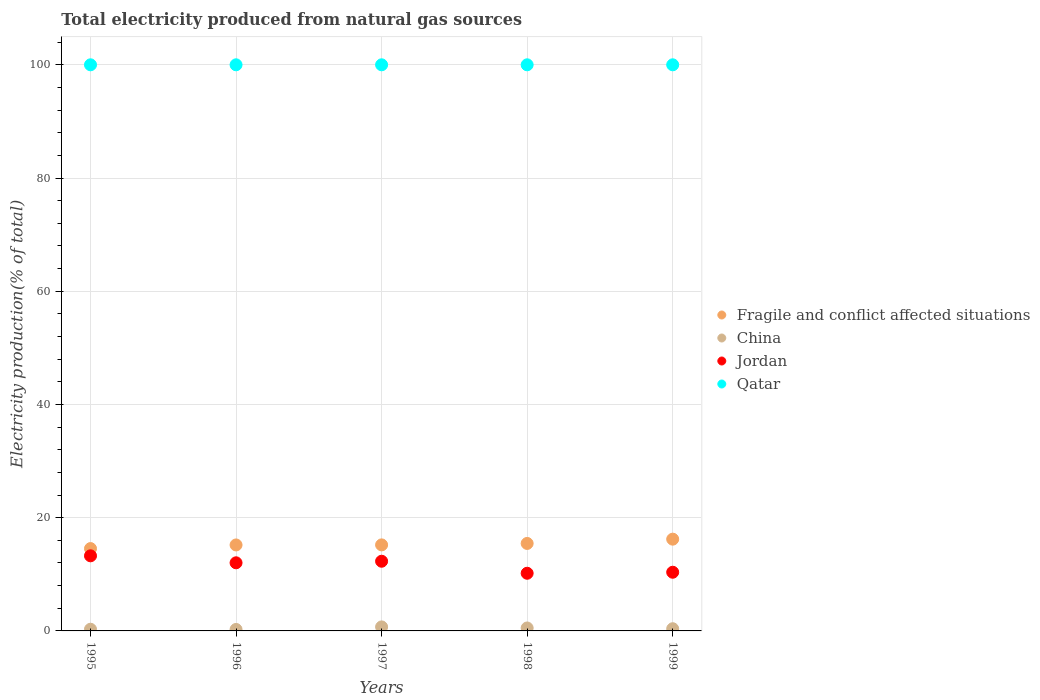Is the number of dotlines equal to the number of legend labels?
Provide a short and direct response. Yes. What is the total electricity produced in Jordan in 1995?
Provide a succinct answer. 13.27. What is the total total electricity produced in Jordan in the graph?
Ensure brevity in your answer.  58.16. What is the difference between the total electricity produced in China in 1996 and that in 1999?
Make the answer very short. -0.13. What is the difference between the total electricity produced in Qatar in 1995 and the total electricity produced in Jordan in 1999?
Make the answer very short. 89.63. In the year 1995, what is the difference between the total electricity produced in Fragile and conflict affected situations and total electricity produced in Jordan?
Make the answer very short. 1.28. In how many years, is the total electricity produced in Qatar greater than 68 %?
Keep it short and to the point. 5. What is the difference between the highest and the second highest total electricity produced in Jordan?
Your answer should be very brief. 0.96. What is the difference between the highest and the lowest total electricity produced in Jordan?
Make the answer very short. 3.08. Is the sum of the total electricity produced in Qatar in 1996 and 1997 greater than the maximum total electricity produced in China across all years?
Your answer should be compact. Yes. Is it the case that in every year, the sum of the total electricity produced in Fragile and conflict affected situations and total electricity produced in Qatar  is greater than the sum of total electricity produced in Jordan and total electricity produced in China?
Make the answer very short. Yes. Is it the case that in every year, the sum of the total electricity produced in Jordan and total electricity produced in China  is greater than the total electricity produced in Fragile and conflict affected situations?
Keep it short and to the point. No. Is the total electricity produced in Jordan strictly less than the total electricity produced in Qatar over the years?
Offer a very short reply. Yes. How many years are there in the graph?
Give a very brief answer. 5. What is the difference between two consecutive major ticks on the Y-axis?
Provide a succinct answer. 20. Are the values on the major ticks of Y-axis written in scientific E-notation?
Your answer should be very brief. No. Does the graph contain any zero values?
Make the answer very short. No. Does the graph contain grids?
Provide a succinct answer. Yes. Where does the legend appear in the graph?
Make the answer very short. Center right. How many legend labels are there?
Offer a very short reply. 4. How are the legend labels stacked?
Keep it short and to the point. Vertical. What is the title of the graph?
Make the answer very short. Total electricity produced from natural gas sources. Does "Morocco" appear as one of the legend labels in the graph?
Your answer should be very brief. No. What is the label or title of the Y-axis?
Your answer should be very brief. Electricity production(% of total). What is the Electricity production(% of total) of Fragile and conflict affected situations in 1995?
Your answer should be very brief. 14.55. What is the Electricity production(% of total) in China in 1995?
Your response must be concise. 0.3. What is the Electricity production(% of total) in Jordan in 1995?
Ensure brevity in your answer.  13.27. What is the Electricity production(% of total) of Qatar in 1995?
Your answer should be compact. 100. What is the Electricity production(% of total) of Fragile and conflict affected situations in 1996?
Offer a very short reply. 15.19. What is the Electricity production(% of total) in China in 1996?
Keep it short and to the point. 0.26. What is the Electricity production(% of total) in Jordan in 1996?
Your response must be concise. 12.03. What is the Electricity production(% of total) in Fragile and conflict affected situations in 1997?
Ensure brevity in your answer.  15.2. What is the Electricity production(% of total) in China in 1997?
Offer a terse response. 0.71. What is the Electricity production(% of total) in Jordan in 1997?
Keep it short and to the point. 12.31. What is the Electricity production(% of total) in Qatar in 1997?
Ensure brevity in your answer.  100. What is the Electricity production(% of total) in Fragile and conflict affected situations in 1998?
Offer a terse response. 15.45. What is the Electricity production(% of total) of China in 1998?
Offer a terse response. 0.52. What is the Electricity production(% of total) in Jordan in 1998?
Your answer should be compact. 10.19. What is the Electricity production(% of total) in Qatar in 1998?
Give a very brief answer. 100. What is the Electricity production(% of total) in Fragile and conflict affected situations in 1999?
Offer a very short reply. 16.21. What is the Electricity production(% of total) of China in 1999?
Your answer should be very brief. 0.39. What is the Electricity production(% of total) in Jordan in 1999?
Make the answer very short. 10.37. What is the Electricity production(% of total) in Qatar in 1999?
Provide a succinct answer. 100. Across all years, what is the maximum Electricity production(% of total) in Fragile and conflict affected situations?
Give a very brief answer. 16.21. Across all years, what is the maximum Electricity production(% of total) of China?
Your answer should be very brief. 0.71. Across all years, what is the maximum Electricity production(% of total) in Jordan?
Give a very brief answer. 13.27. Across all years, what is the maximum Electricity production(% of total) of Qatar?
Give a very brief answer. 100. Across all years, what is the minimum Electricity production(% of total) in Fragile and conflict affected situations?
Provide a short and direct response. 14.55. Across all years, what is the minimum Electricity production(% of total) in China?
Provide a succinct answer. 0.26. Across all years, what is the minimum Electricity production(% of total) of Jordan?
Your answer should be compact. 10.19. What is the total Electricity production(% of total) of Fragile and conflict affected situations in the graph?
Provide a succinct answer. 76.59. What is the total Electricity production(% of total) of China in the graph?
Make the answer very short. 2.17. What is the total Electricity production(% of total) of Jordan in the graph?
Offer a very short reply. 58.16. What is the total Electricity production(% of total) of Qatar in the graph?
Offer a very short reply. 500. What is the difference between the Electricity production(% of total) of Fragile and conflict affected situations in 1995 and that in 1996?
Provide a short and direct response. -0.64. What is the difference between the Electricity production(% of total) of China in 1995 and that in 1996?
Keep it short and to the point. 0.04. What is the difference between the Electricity production(% of total) of Jordan in 1995 and that in 1996?
Your answer should be very brief. 1.23. What is the difference between the Electricity production(% of total) of Fragile and conflict affected situations in 1995 and that in 1997?
Make the answer very short. -0.65. What is the difference between the Electricity production(% of total) in China in 1995 and that in 1997?
Provide a succinct answer. -0.41. What is the difference between the Electricity production(% of total) of Jordan in 1995 and that in 1997?
Give a very brief answer. 0.96. What is the difference between the Electricity production(% of total) in Fragile and conflict affected situations in 1995 and that in 1998?
Keep it short and to the point. -0.91. What is the difference between the Electricity production(% of total) in China in 1995 and that in 1998?
Give a very brief answer. -0.22. What is the difference between the Electricity production(% of total) in Jordan in 1995 and that in 1998?
Give a very brief answer. 3.08. What is the difference between the Electricity production(% of total) of Qatar in 1995 and that in 1998?
Keep it short and to the point. 0. What is the difference between the Electricity production(% of total) in Fragile and conflict affected situations in 1995 and that in 1999?
Provide a succinct answer. -1.66. What is the difference between the Electricity production(% of total) in China in 1995 and that in 1999?
Provide a succinct answer. -0.09. What is the difference between the Electricity production(% of total) in Jordan in 1995 and that in 1999?
Offer a terse response. 2.9. What is the difference between the Electricity production(% of total) in Fragile and conflict affected situations in 1996 and that in 1997?
Give a very brief answer. -0.01. What is the difference between the Electricity production(% of total) of China in 1996 and that in 1997?
Ensure brevity in your answer.  -0.45. What is the difference between the Electricity production(% of total) in Jordan in 1996 and that in 1997?
Your answer should be very brief. -0.27. What is the difference between the Electricity production(% of total) in Qatar in 1996 and that in 1997?
Offer a terse response. 0. What is the difference between the Electricity production(% of total) in Fragile and conflict affected situations in 1996 and that in 1998?
Provide a succinct answer. -0.27. What is the difference between the Electricity production(% of total) in China in 1996 and that in 1998?
Offer a terse response. -0.26. What is the difference between the Electricity production(% of total) of Jordan in 1996 and that in 1998?
Make the answer very short. 1.85. What is the difference between the Electricity production(% of total) in Qatar in 1996 and that in 1998?
Offer a terse response. 0. What is the difference between the Electricity production(% of total) in Fragile and conflict affected situations in 1996 and that in 1999?
Offer a very short reply. -1.02. What is the difference between the Electricity production(% of total) in China in 1996 and that in 1999?
Your response must be concise. -0.13. What is the difference between the Electricity production(% of total) in Jordan in 1996 and that in 1999?
Make the answer very short. 1.67. What is the difference between the Electricity production(% of total) in Qatar in 1996 and that in 1999?
Provide a succinct answer. 0. What is the difference between the Electricity production(% of total) of Fragile and conflict affected situations in 1997 and that in 1998?
Offer a terse response. -0.26. What is the difference between the Electricity production(% of total) of China in 1997 and that in 1998?
Give a very brief answer. 0.19. What is the difference between the Electricity production(% of total) of Jordan in 1997 and that in 1998?
Your answer should be very brief. 2.12. What is the difference between the Electricity production(% of total) in Qatar in 1997 and that in 1998?
Offer a terse response. 0. What is the difference between the Electricity production(% of total) in Fragile and conflict affected situations in 1997 and that in 1999?
Make the answer very short. -1.01. What is the difference between the Electricity production(% of total) of China in 1997 and that in 1999?
Ensure brevity in your answer.  0.32. What is the difference between the Electricity production(% of total) of Jordan in 1997 and that in 1999?
Ensure brevity in your answer.  1.94. What is the difference between the Electricity production(% of total) of Qatar in 1997 and that in 1999?
Your answer should be compact. 0. What is the difference between the Electricity production(% of total) of Fragile and conflict affected situations in 1998 and that in 1999?
Provide a short and direct response. -0.76. What is the difference between the Electricity production(% of total) in China in 1998 and that in 1999?
Provide a short and direct response. 0.13. What is the difference between the Electricity production(% of total) of Jordan in 1998 and that in 1999?
Provide a succinct answer. -0.18. What is the difference between the Electricity production(% of total) in Fragile and conflict affected situations in 1995 and the Electricity production(% of total) in China in 1996?
Offer a terse response. 14.29. What is the difference between the Electricity production(% of total) of Fragile and conflict affected situations in 1995 and the Electricity production(% of total) of Jordan in 1996?
Your answer should be very brief. 2.51. What is the difference between the Electricity production(% of total) in Fragile and conflict affected situations in 1995 and the Electricity production(% of total) in Qatar in 1996?
Provide a succinct answer. -85.45. What is the difference between the Electricity production(% of total) in China in 1995 and the Electricity production(% of total) in Jordan in 1996?
Provide a short and direct response. -11.74. What is the difference between the Electricity production(% of total) of China in 1995 and the Electricity production(% of total) of Qatar in 1996?
Give a very brief answer. -99.7. What is the difference between the Electricity production(% of total) in Jordan in 1995 and the Electricity production(% of total) in Qatar in 1996?
Provide a succinct answer. -86.73. What is the difference between the Electricity production(% of total) of Fragile and conflict affected situations in 1995 and the Electricity production(% of total) of China in 1997?
Offer a terse response. 13.84. What is the difference between the Electricity production(% of total) in Fragile and conflict affected situations in 1995 and the Electricity production(% of total) in Jordan in 1997?
Ensure brevity in your answer.  2.24. What is the difference between the Electricity production(% of total) in Fragile and conflict affected situations in 1995 and the Electricity production(% of total) in Qatar in 1997?
Ensure brevity in your answer.  -85.45. What is the difference between the Electricity production(% of total) in China in 1995 and the Electricity production(% of total) in Jordan in 1997?
Your answer should be compact. -12.01. What is the difference between the Electricity production(% of total) in China in 1995 and the Electricity production(% of total) in Qatar in 1997?
Offer a very short reply. -99.7. What is the difference between the Electricity production(% of total) of Jordan in 1995 and the Electricity production(% of total) of Qatar in 1997?
Provide a short and direct response. -86.73. What is the difference between the Electricity production(% of total) in Fragile and conflict affected situations in 1995 and the Electricity production(% of total) in China in 1998?
Ensure brevity in your answer.  14.03. What is the difference between the Electricity production(% of total) in Fragile and conflict affected situations in 1995 and the Electricity production(% of total) in Jordan in 1998?
Provide a short and direct response. 4.36. What is the difference between the Electricity production(% of total) of Fragile and conflict affected situations in 1995 and the Electricity production(% of total) of Qatar in 1998?
Ensure brevity in your answer.  -85.45. What is the difference between the Electricity production(% of total) of China in 1995 and the Electricity production(% of total) of Jordan in 1998?
Your answer should be compact. -9.89. What is the difference between the Electricity production(% of total) in China in 1995 and the Electricity production(% of total) in Qatar in 1998?
Your answer should be compact. -99.7. What is the difference between the Electricity production(% of total) of Jordan in 1995 and the Electricity production(% of total) of Qatar in 1998?
Offer a very short reply. -86.73. What is the difference between the Electricity production(% of total) of Fragile and conflict affected situations in 1995 and the Electricity production(% of total) of China in 1999?
Your answer should be very brief. 14.16. What is the difference between the Electricity production(% of total) of Fragile and conflict affected situations in 1995 and the Electricity production(% of total) of Jordan in 1999?
Offer a very short reply. 4.18. What is the difference between the Electricity production(% of total) in Fragile and conflict affected situations in 1995 and the Electricity production(% of total) in Qatar in 1999?
Your answer should be very brief. -85.45. What is the difference between the Electricity production(% of total) in China in 1995 and the Electricity production(% of total) in Jordan in 1999?
Give a very brief answer. -10.07. What is the difference between the Electricity production(% of total) of China in 1995 and the Electricity production(% of total) of Qatar in 1999?
Make the answer very short. -99.7. What is the difference between the Electricity production(% of total) in Jordan in 1995 and the Electricity production(% of total) in Qatar in 1999?
Offer a very short reply. -86.73. What is the difference between the Electricity production(% of total) of Fragile and conflict affected situations in 1996 and the Electricity production(% of total) of China in 1997?
Provide a succinct answer. 14.48. What is the difference between the Electricity production(% of total) in Fragile and conflict affected situations in 1996 and the Electricity production(% of total) in Jordan in 1997?
Ensure brevity in your answer.  2.88. What is the difference between the Electricity production(% of total) of Fragile and conflict affected situations in 1996 and the Electricity production(% of total) of Qatar in 1997?
Your answer should be very brief. -84.81. What is the difference between the Electricity production(% of total) of China in 1996 and the Electricity production(% of total) of Jordan in 1997?
Make the answer very short. -12.05. What is the difference between the Electricity production(% of total) of China in 1996 and the Electricity production(% of total) of Qatar in 1997?
Provide a short and direct response. -99.74. What is the difference between the Electricity production(% of total) in Jordan in 1996 and the Electricity production(% of total) in Qatar in 1997?
Keep it short and to the point. -87.97. What is the difference between the Electricity production(% of total) in Fragile and conflict affected situations in 1996 and the Electricity production(% of total) in China in 1998?
Ensure brevity in your answer.  14.67. What is the difference between the Electricity production(% of total) in Fragile and conflict affected situations in 1996 and the Electricity production(% of total) in Jordan in 1998?
Provide a short and direct response. 5. What is the difference between the Electricity production(% of total) in Fragile and conflict affected situations in 1996 and the Electricity production(% of total) in Qatar in 1998?
Offer a very short reply. -84.81. What is the difference between the Electricity production(% of total) of China in 1996 and the Electricity production(% of total) of Jordan in 1998?
Your answer should be compact. -9.92. What is the difference between the Electricity production(% of total) of China in 1996 and the Electricity production(% of total) of Qatar in 1998?
Your response must be concise. -99.74. What is the difference between the Electricity production(% of total) in Jordan in 1996 and the Electricity production(% of total) in Qatar in 1998?
Offer a very short reply. -87.97. What is the difference between the Electricity production(% of total) of Fragile and conflict affected situations in 1996 and the Electricity production(% of total) of China in 1999?
Keep it short and to the point. 14.8. What is the difference between the Electricity production(% of total) of Fragile and conflict affected situations in 1996 and the Electricity production(% of total) of Jordan in 1999?
Give a very brief answer. 4.82. What is the difference between the Electricity production(% of total) of Fragile and conflict affected situations in 1996 and the Electricity production(% of total) of Qatar in 1999?
Offer a terse response. -84.81. What is the difference between the Electricity production(% of total) of China in 1996 and the Electricity production(% of total) of Jordan in 1999?
Your answer should be compact. -10.1. What is the difference between the Electricity production(% of total) in China in 1996 and the Electricity production(% of total) in Qatar in 1999?
Keep it short and to the point. -99.74. What is the difference between the Electricity production(% of total) of Jordan in 1996 and the Electricity production(% of total) of Qatar in 1999?
Your response must be concise. -87.97. What is the difference between the Electricity production(% of total) in Fragile and conflict affected situations in 1997 and the Electricity production(% of total) in China in 1998?
Make the answer very short. 14.68. What is the difference between the Electricity production(% of total) of Fragile and conflict affected situations in 1997 and the Electricity production(% of total) of Jordan in 1998?
Make the answer very short. 5.01. What is the difference between the Electricity production(% of total) in Fragile and conflict affected situations in 1997 and the Electricity production(% of total) in Qatar in 1998?
Your answer should be compact. -84.8. What is the difference between the Electricity production(% of total) of China in 1997 and the Electricity production(% of total) of Jordan in 1998?
Your response must be concise. -9.48. What is the difference between the Electricity production(% of total) in China in 1997 and the Electricity production(% of total) in Qatar in 1998?
Your response must be concise. -99.29. What is the difference between the Electricity production(% of total) of Jordan in 1997 and the Electricity production(% of total) of Qatar in 1998?
Make the answer very short. -87.69. What is the difference between the Electricity production(% of total) in Fragile and conflict affected situations in 1997 and the Electricity production(% of total) in China in 1999?
Give a very brief answer. 14.81. What is the difference between the Electricity production(% of total) of Fragile and conflict affected situations in 1997 and the Electricity production(% of total) of Jordan in 1999?
Your answer should be very brief. 4.83. What is the difference between the Electricity production(% of total) of Fragile and conflict affected situations in 1997 and the Electricity production(% of total) of Qatar in 1999?
Give a very brief answer. -84.8. What is the difference between the Electricity production(% of total) of China in 1997 and the Electricity production(% of total) of Jordan in 1999?
Your answer should be compact. -9.66. What is the difference between the Electricity production(% of total) of China in 1997 and the Electricity production(% of total) of Qatar in 1999?
Your answer should be compact. -99.29. What is the difference between the Electricity production(% of total) of Jordan in 1997 and the Electricity production(% of total) of Qatar in 1999?
Make the answer very short. -87.69. What is the difference between the Electricity production(% of total) of Fragile and conflict affected situations in 1998 and the Electricity production(% of total) of China in 1999?
Your answer should be compact. 15.07. What is the difference between the Electricity production(% of total) in Fragile and conflict affected situations in 1998 and the Electricity production(% of total) in Jordan in 1999?
Provide a succinct answer. 5.09. What is the difference between the Electricity production(% of total) in Fragile and conflict affected situations in 1998 and the Electricity production(% of total) in Qatar in 1999?
Ensure brevity in your answer.  -84.55. What is the difference between the Electricity production(% of total) of China in 1998 and the Electricity production(% of total) of Jordan in 1999?
Your answer should be compact. -9.85. What is the difference between the Electricity production(% of total) in China in 1998 and the Electricity production(% of total) in Qatar in 1999?
Ensure brevity in your answer.  -99.48. What is the difference between the Electricity production(% of total) of Jordan in 1998 and the Electricity production(% of total) of Qatar in 1999?
Offer a terse response. -89.81. What is the average Electricity production(% of total) in Fragile and conflict affected situations per year?
Make the answer very short. 15.32. What is the average Electricity production(% of total) of China per year?
Your response must be concise. 0.43. What is the average Electricity production(% of total) of Jordan per year?
Your answer should be very brief. 11.63. In the year 1995, what is the difference between the Electricity production(% of total) of Fragile and conflict affected situations and Electricity production(% of total) of China?
Offer a very short reply. 14.25. In the year 1995, what is the difference between the Electricity production(% of total) of Fragile and conflict affected situations and Electricity production(% of total) of Jordan?
Give a very brief answer. 1.28. In the year 1995, what is the difference between the Electricity production(% of total) in Fragile and conflict affected situations and Electricity production(% of total) in Qatar?
Provide a short and direct response. -85.45. In the year 1995, what is the difference between the Electricity production(% of total) of China and Electricity production(% of total) of Jordan?
Make the answer very short. -12.97. In the year 1995, what is the difference between the Electricity production(% of total) in China and Electricity production(% of total) in Qatar?
Your answer should be compact. -99.7. In the year 1995, what is the difference between the Electricity production(% of total) in Jordan and Electricity production(% of total) in Qatar?
Provide a succinct answer. -86.73. In the year 1996, what is the difference between the Electricity production(% of total) of Fragile and conflict affected situations and Electricity production(% of total) of China?
Your response must be concise. 14.93. In the year 1996, what is the difference between the Electricity production(% of total) in Fragile and conflict affected situations and Electricity production(% of total) in Jordan?
Keep it short and to the point. 3.15. In the year 1996, what is the difference between the Electricity production(% of total) of Fragile and conflict affected situations and Electricity production(% of total) of Qatar?
Your response must be concise. -84.81. In the year 1996, what is the difference between the Electricity production(% of total) in China and Electricity production(% of total) in Jordan?
Give a very brief answer. -11.77. In the year 1996, what is the difference between the Electricity production(% of total) in China and Electricity production(% of total) in Qatar?
Your answer should be compact. -99.74. In the year 1996, what is the difference between the Electricity production(% of total) in Jordan and Electricity production(% of total) in Qatar?
Offer a terse response. -87.97. In the year 1997, what is the difference between the Electricity production(% of total) of Fragile and conflict affected situations and Electricity production(% of total) of China?
Ensure brevity in your answer.  14.49. In the year 1997, what is the difference between the Electricity production(% of total) of Fragile and conflict affected situations and Electricity production(% of total) of Jordan?
Keep it short and to the point. 2.89. In the year 1997, what is the difference between the Electricity production(% of total) of Fragile and conflict affected situations and Electricity production(% of total) of Qatar?
Ensure brevity in your answer.  -84.8. In the year 1997, what is the difference between the Electricity production(% of total) in China and Electricity production(% of total) in Jordan?
Provide a short and direct response. -11.6. In the year 1997, what is the difference between the Electricity production(% of total) in China and Electricity production(% of total) in Qatar?
Ensure brevity in your answer.  -99.29. In the year 1997, what is the difference between the Electricity production(% of total) of Jordan and Electricity production(% of total) of Qatar?
Offer a terse response. -87.69. In the year 1998, what is the difference between the Electricity production(% of total) in Fragile and conflict affected situations and Electricity production(% of total) in China?
Provide a succinct answer. 14.93. In the year 1998, what is the difference between the Electricity production(% of total) in Fragile and conflict affected situations and Electricity production(% of total) in Jordan?
Make the answer very short. 5.27. In the year 1998, what is the difference between the Electricity production(% of total) of Fragile and conflict affected situations and Electricity production(% of total) of Qatar?
Offer a terse response. -84.55. In the year 1998, what is the difference between the Electricity production(% of total) in China and Electricity production(% of total) in Jordan?
Offer a terse response. -9.66. In the year 1998, what is the difference between the Electricity production(% of total) of China and Electricity production(% of total) of Qatar?
Make the answer very short. -99.48. In the year 1998, what is the difference between the Electricity production(% of total) of Jordan and Electricity production(% of total) of Qatar?
Offer a terse response. -89.81. In the year 1999, what is the difference between the Electricity production(% of total) in Fragile and conflict affected situations and Electricity production(% of total) in China?
Your answer should be compact. 15.82. In the year 1999, what is the difference between the Electricity production(% of total) in Fragile and conflict affected situations and Electricity production(% of total) in Jordan?
Make the answer very short. 5.84. In the year 1999, what is the difference between the Electricity production(% of total) in Fragile and conflict affected situations and Electricity production(% of total) in Qatar?
Provide a succinct answer. -83.79. In the year 1999, what is the difference between the Electricity production(% of total) of China and Electricity production(% of total) of Jordan?
Ensure brevity in your answer.  -9.98. In the year 1999, what is the difference between the Electricity production(% of total) of China and Electricity production(% of total) of Qatar?
Make the answer very short. -99.61. In the year 1999, what is the difference between the Electricity production(% of total) in Jordan and Electricity production(% of total) in Qatar?
Your answer should be compact. -89.63. What is the ratio of the Electricity production(% of total) in Fragile and conflict affected situations in 1995 to that in 1996?
Your answer should be compact. 0.96. What is the ratio of the Electricity production(% of total) of China in 1995 to that in 1996?
Ensure brevity in your answer.  1.14. What is the ratio of the Electricity production(% of total) in Jordan in 1995 to that in 1996?
Your answer should be compact. 1.1. What is the ratio of the Electricity production(% of total) in Qatar in 1995 to that in 1996?
Provide a short and direct response. 1. What is the ratio of the Electricity production(% of total) in Fragile and conflict affected situations in 1995 to that in 1997?
Make the answer very short. 0.96. What is the ratio of the Electricity production(% of total) of China in 1995 to that in 1997?
Make the answer very short. 0.42. What is the ratio of the Electricity production(% of total) of Jordan in 1995 to that in 1997?
Ensure brevity in your answer.  1.08. What is the ratio of the Electricity production(% of total) in Fragile and conflict affected situations in 1995 to that in 1998?
Offer a very short reply. 0.94. What is the ratio of the Electricity production(% of total) in China in 1995 to that in 1998?
Give a very brief answer. 0.57. What is the ratio of the Electricity production(% of total) of Jordan in 1995 to that in 1998?
Keep it short and to the point. 1.3. What is the ratio of the Electricity production(% of total) of Fragile and conflict affected situations in 1995 to that in 1999?
Provide a succinct answer. 0.9. What is the ratio of the Electricity production(% of total) of China in 1995 to that in 1999?
Provide a short and direct response. 0.77. What is the ratio of the Electricity production(% of total) of Jordan in 1995 to that in 1999?
Offer a very short reply. 1.28. What is the ratio of the Electricity production(% of total) of Qatar in 1995 to that in 1999?
Your answer should be very brief. 1. What is the ratio of the Electricity production(% of total) of China in 1996 to that in 1997?
Provide a short and direct response. 0.37. What is the ratio of the Electricity production(% of total) of Jordan in 1996 to that in 1997?
Keep it short and to the point. 0.98. What is the ratio of the Electricity production(% of total) in Fragile and conflict affected situations in 1996 to that in 1998?
Make the answer very short. 0.98. What is the ratio of the Electricity production(% of total) in China in 1996 to that in 1998?
Provide a short and direct response. 0.5. What is the ratio of the Electricity production(% of total) in Jordan in 1996 to that in 1998?
Provide a succinct answer. 1.18. What is the ratio of the Electricity production(% of total) in Fragile and conflict affected situations in 1996 to that in 1999?
Make the answer very short. 0.94. What is the ratio of the Electricity production(% of total) of China in 1996 to that in 1999?
Give a very brief answer. 0.67. What is the ratio of the Electricity production(% of total) in Jordan in 1996 to that in 1999?
Offer a terse response. 1.16. What is the ratio of the Electricity production(% of total) in Qatar in 1996 to that in 1999?
Keep it short and to the point. 1. What is the ratio of the Electricity production(% of total) in Fragile and conflict affected situations in 1997 to that in 1998?
Offer a terse response. 0.98. What is the ratio of the Electricity production(% of total) of China in 1997 to that in 1998?
Keep it short and to the point. 1.36. What is the ratio of the Electricity production(% of total) of Jordan in 1997 to that in 1998?
Make the answer very short. 1.21. What is the ratio of the Electricity production(% of total) of Fragile and conflict affected situations in 1997 to that in 1999?
Make the answer very short. 0.94. What is the ratio of the Electricity production(% of total) of China in 1997 to that in 1999?
Provide a short and direct response. 1.83. What is the ratio of the Electricity production(% of total) in Jordan in 1997 to that in 1999?
Provide a short and direct response. 1.19. What is the ratio of the Electricity production(% of total) in Fragile and conflict affected situations in 1998 to that in 1999?
Keep it short and to the point. 0.95. What is the ratio of the Electricity production(% of total) in China in 1998 to that in 1999?
Make the answer very short. 1.34. What is the ratio of the Electricity production(% of total) of Jordan in 1998 to that in 1999?
Give a very brief answer. 0.98. What is the ratio of the Electricity production(% of total) of Qatar in 1998 to that in 1999?
Keep it short and to the point. 1. What is the difference between the highest and the second highest Electricity production(% of total) of Fragile and conflict affected situations?
Your response must be concise. 0.76. What is the difference between the highest and the second highest Electricity production(% of total) in China?
Provide a short and direct response. 0.19. What is the difference between the highest and the second highest Electricity production(% of total) of Jordan?
Your answer should be very brief. 0.96. What is the difference between the highest and the second highest Electricity production(% of total) in Qatar?
Provide a succinct answer. 0. What is the difference between the highest and the lowest Electricity production(% of total) in Fragile and conflict affected situations?
Your answer should be compact. 1.66. What is the difference between the highest and the lowest Electricity production(% of total) in China?
Keep it short and to the point. 0.45. What is the difference between the highest and the lowest Electricity production(% of total) of Jordan?
Offer a terse response. 3.08. What is the difference between the highest and the lowest Electricity production(% of total) in Qatar?
Your response must be concise. 0. 